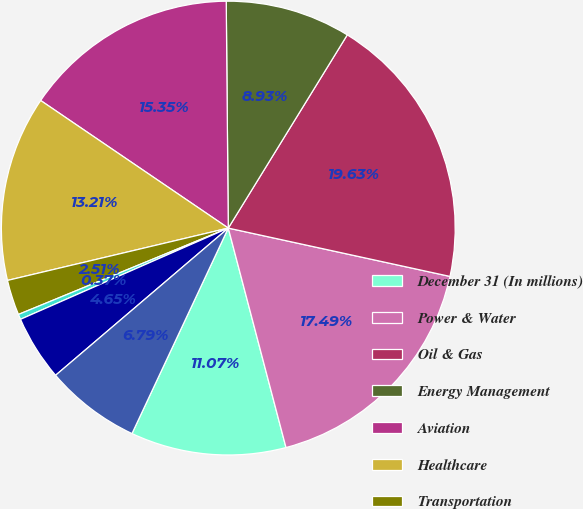<chart> <loc_0><loc_0><loc_500><loc_500><pie_chart><fcel>December 31 (In millions)<fcel>Power & Water<fcel>Oil & Gas<fcel>Energy Management<fcel>Aviation<fcel>Healthcare<fcel>Transportation<fcel>Home & Business Solutions<fcel>Corporate items and<fcel>Less allowance for losses<nl><fcel>11.07%<fcel>17.49%<fcel>19.63%<fcel>8.93%<fcel>15.35%<fcel>13.21%<fcel>2.51%<fcel>0.37%<fcel>4.65%<fcel>6.79%<nl></chart> 